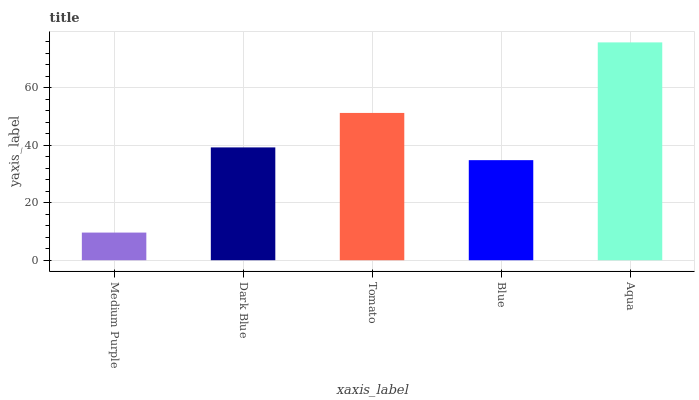Is Medium Purple the minimum?
Answer yes or no. Yes. Is Aqua the maximum?
Answer yes or no. Yes. Is Dark Blue the minimum?
Answer yes or no. No. Is Dark Blue the maximum?
Answer yes or no. No. Is Dark Blue greater than Medium Purple?
Answer yes or no. Yes. Is Medium Purple less than Dark Blue?
Answer yes or no. Yes. Is Medium Purple greater than Dark Blue?
Answer yes or no. No. Is Dark Blue less than Medium Purple?
Answer yes or no. No. Is Dark Blue the high median?
Answer yes or no. Yes. Is Dark Blue the low median?
Answer yes or no. Yes. Is Aqua the high median?
Answer yes or no. No. Is Aqua the low median?
Answer yes or no. No. 